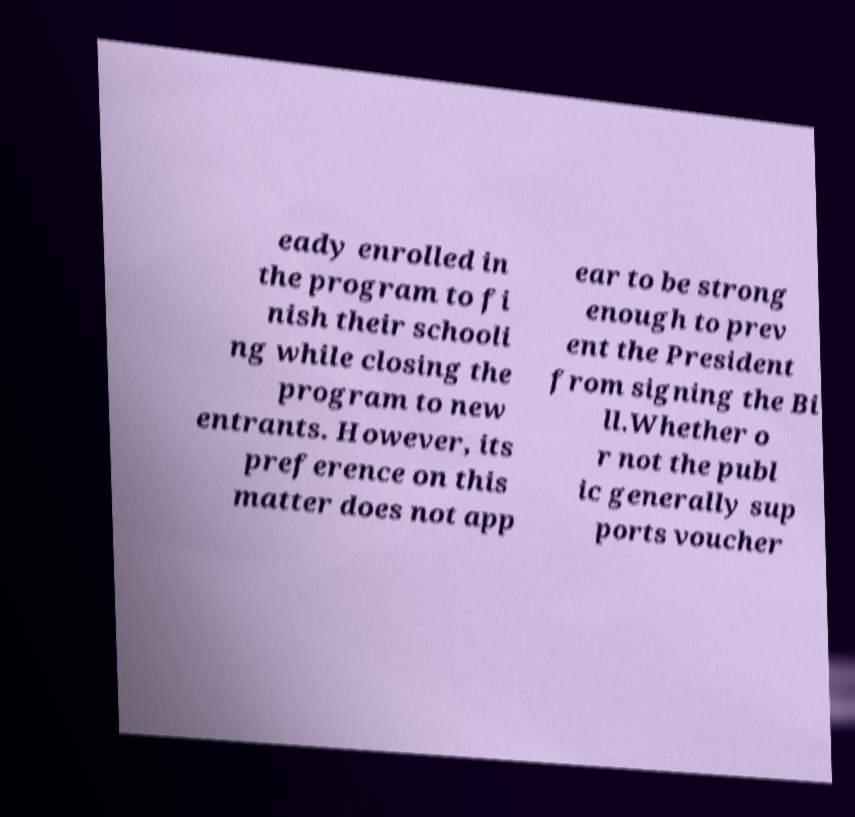Please read and relay the text visible in this image. What does it say? eady enrolled in the program to fi nish their schooli ng while closing the program to new entrants. However, its preference on this matter does not app ear to be strong enough to prev ent the President from signing the Bi ll.Whether o r not the publ ic generally sup ports voucher 